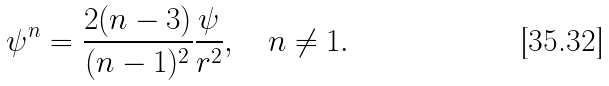<formula> <loc_0><loc_0><loc_500><loc_500>\psi ^ { n } = \frac { 2 ( n - 3 ) } { ( n - 1 ) ^ { 2 } } \frac { \psi } { r ^ { 2 } } , \quad n \neq 1 .</formula> 